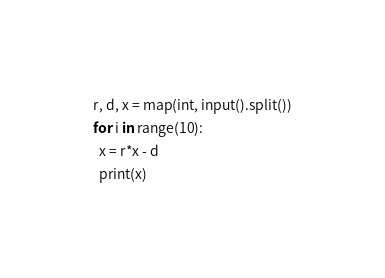<code> <loc_0><loc_0><loc_500><loc_500><_Python_>r, d, x = map(int, input().split())
for i in range(10):
  x = r*x - d
  print(x)</code> 